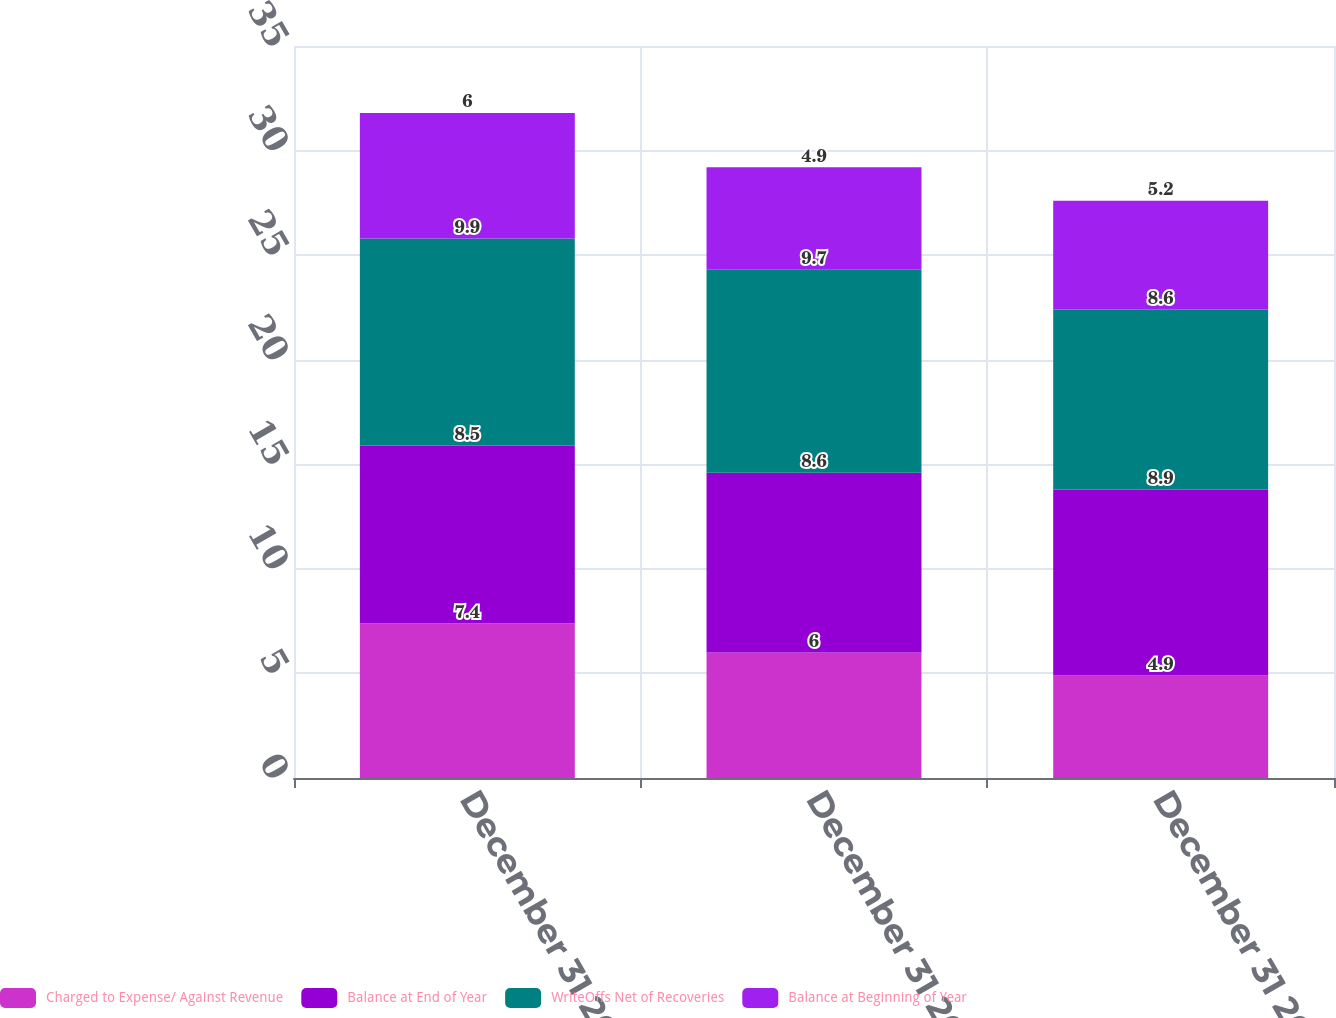Convert chart to OTSL. <chart><loc_0><loc_0><loc_500><loc_500><stacked_bar_chart><ecel><fcel>December 31 2006<fcel>December 31 2007<fcel>December 31 2008<nl><fcel>Charged to Expense/ Against Revenue<fcel>7.4<fcel>6<fcel>4.9<nl><fcel>Balance at End of Year<fcel>8.5<fcel>8.6<fcel>8.9<nl><fcel>WriteOffs Net of Recoveries<fcel>9.9<fcel>9.7<fcel>8.6<nl><fcel>Balance at Beginning of Year<fcel>6<fcel>4.9<fcel>5.2<nl></chart> 